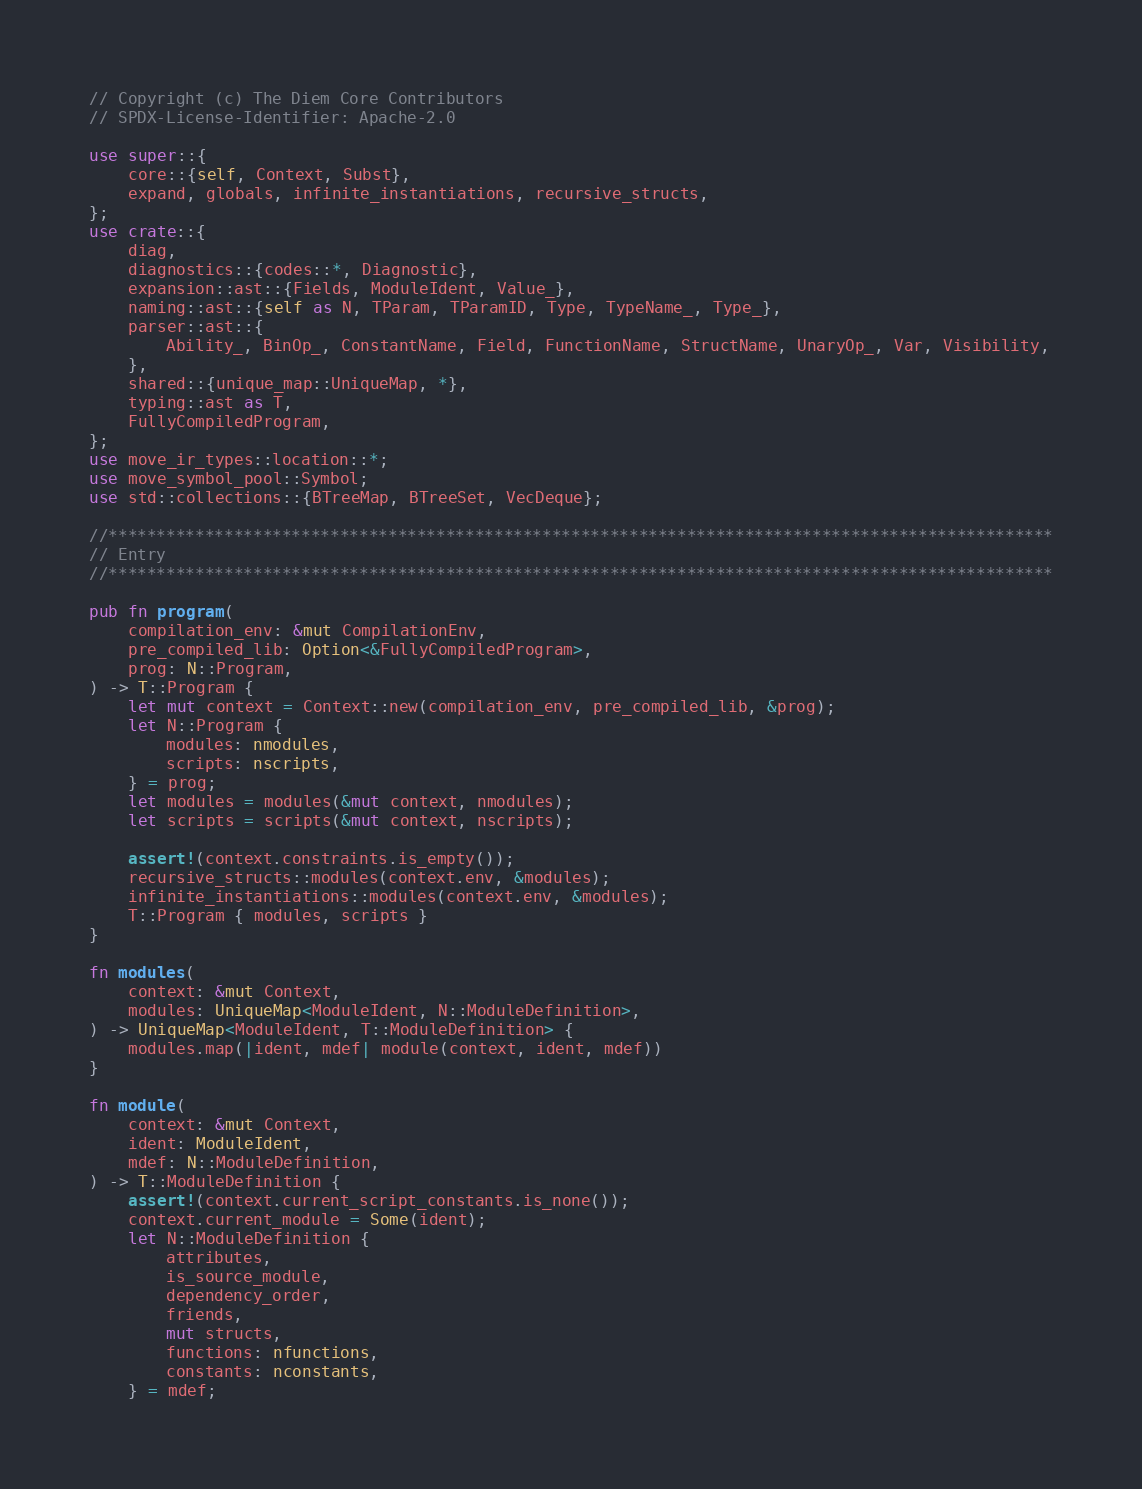Convert code to text. <code><loc_0><loc_0><loc_500><loc_500><_Rust_>// Copyright (c) The Diem Core Contributors
// SPDX-License-Identifier: Apache-2.0

use super::{
    core::{self, Context, Subst},
    expand, globals, infinite_instantiations, recursive_structs,
};
use crate::{
    diag,
    diagnostics::{codes::*, Diagnostic},
    expansion::ast::{Fields, ModuleIdent, Value_},
    naming::ast::{self as N, TParam, TParamID, Type, TypeName_, Type_},
    parser::ast::{
        Ability_, BinOp_, ConstantName, Field, FunctionName, StructName, UnaryOp_, Var, Visibility,
    },
    shared::{unique_map::UniqueMap, *},
    typing::ast as T,
    FullyCompiledProgram,
};
use move_ir_types::location::*;
use move_symbol_pool::Symbol;
use std::collections::{BTreeMap, BTreeSet, VecDeque};

//**************************************************************************************************
// Entry
//**************************************************************************************************

pub fn program(
    compilation_env: &mut CompilationEnv,
    pre_compiled_lib: Option<&FullyCompiledProgram>,
    prog: N::Program,
) -> T::Program {
    let mut context = Context::new(compilation_env, pre_compiled_lib, &prog);
    let N::Program {
        modules: nmodules,
        scripts: nscripts,
    } = prog;
    let modules = modules(&mut context, nmodules);
    let scripts = scripts(&mut context, nscripts);

    assert!(context.constraints.is_empty());
    recursive_structs::modules(context.env, &modules);
    infinite_instantiations::modules(context.env, &modules);
    T::Program { modules, scripts }
}

fn modules(
    context: &mut Context,
    modules: UniqueMap<ModuleIdent, N::ModuleDefinition>,
) -> UniqueMap<ModuleIdent, T::ModuleDefinition> {
    modules.map(|ident, mdef| module(context, ident, mdef))
}

fn module(
    context: &mut Context,
    ident: ModuleIdent,
    mdef: N::ModuleDefinition,
) -> T::ModuleDefinition {
    assert!(context.current_script_constants.is_none());
    context.current_module = Some(ident);
    let N::ModuleDefinition {
        attributes,
        is_source_module,
        dependency_order,
        friends,
        mut structs,
        functions: nfunctions,
        constants: nconstants,
    } = mdef;</code> 